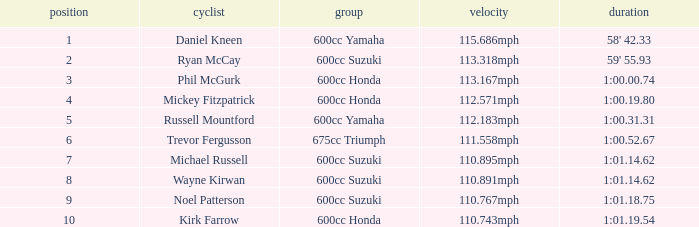What time has phil mcgurk as the rider? 1:00.00.74. 